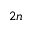Convert formula to latex. <formula><loc_0><loc_0><loc_500><loc_500>2 n</formula> 